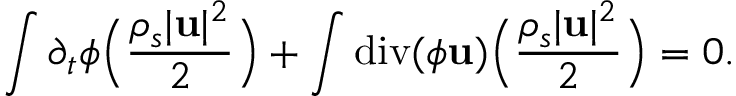<formula> <loc_0><loc_0><loc_500><loc_500>\int \partial _ { t } \phi \left ( \frac { \rho _ { s } | { u } | ^ { 2 } } { 2 } \right ) + \int d i v ( \phi { u } ) \left ( \frac { \rho _ { s } | { u } | ^ { 2 } } { 2 } \right ) = 0 .</formula> 